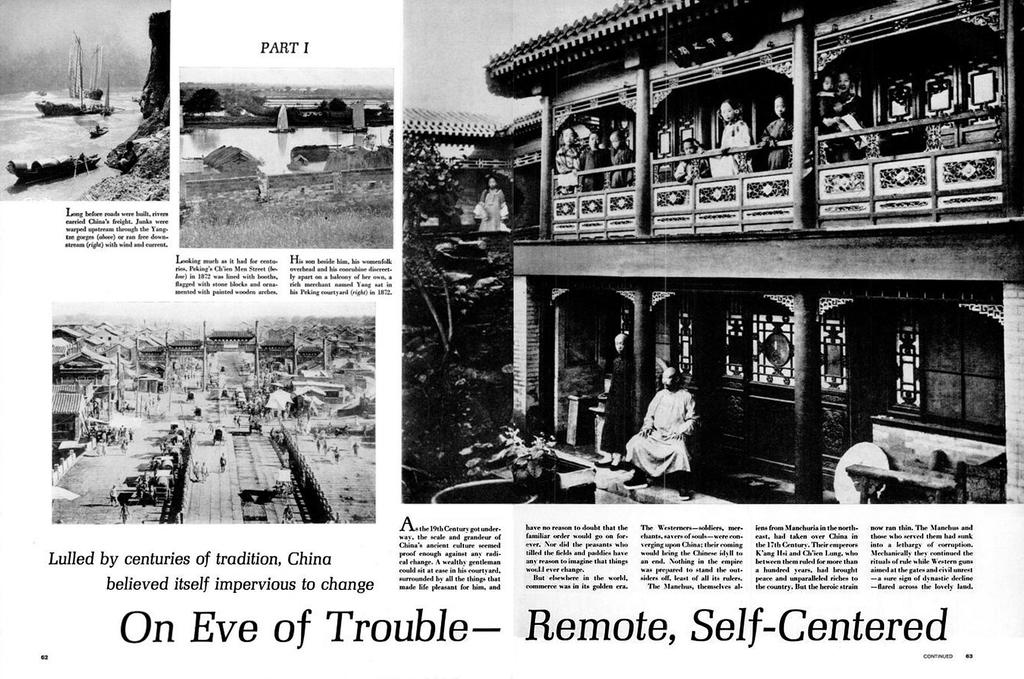What is the main object in the image? The image contains a newspaper. What can be found on the newspaper? There are photos and paragraphs on the newspaper. How many legs can be seen on the pies in the image? There are no pies present in the image, and therefore no legs can be seen on them. 